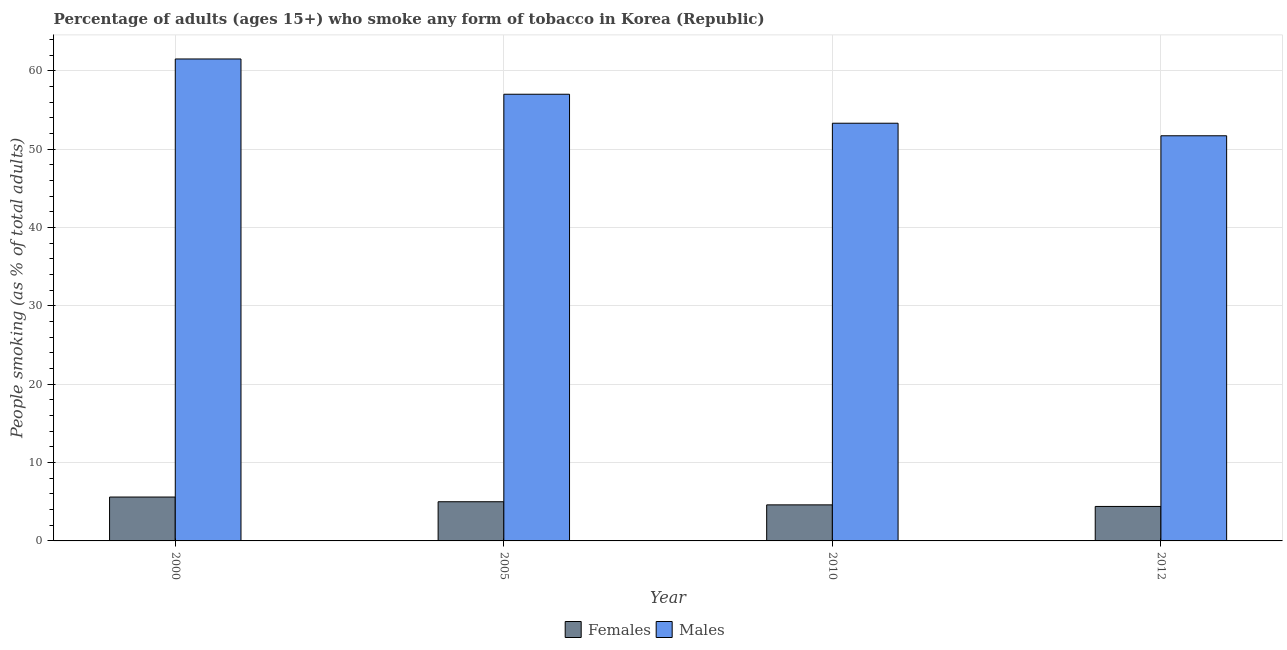How many different coloured bars are there?
Give a very brief answer. 2. Are the number of bars per tick equal to the number of legend labels?
Offer a terse response. Yes. How many bars are there on the 1st tick from the right?
Give a very brief answer. 2. What is the label of the 2nd group of bars from the left?
Offer a very short reply. 2005. In how many cases, is the number of bars for a given year not equal to the number of legend labels?
Keep it short and to the point. 0. Across all years, what is the minimum percentage of males who smoke?
Ensure brevity in your answer.  51.7. In which year was the percentage of females who smoke maximum?
Your answer should be compact. 2000. What is the total percentage of males who smoke in the graph?
Offer a terse response. 223.5. What is the difference between the percentage of females who smoke in 2000 and that in 2012?
Offer a terse response. 1.2. What is the average percentage of males who smoke per year?
Provide a short and direct response. 55.88. In the year 2005, what is the difference between the percentage of males who smoke and percentage of females who smoke?
Your answer should be very brief. 0. What is the ratio of the percentage of females who smoke in 2000 to that in 2012?
Your answer should be very brief. 1.27. Is the percentage of females who smoke in 2005 less than that in 2010?
Make the answer very short. No. What is the difference between the highest and the second highest percentage of males who smoke?
Provide a succinct answer. 4.5. What is the difference between the highest and the lowest percentage of females who smoke?
Your answer should be compact. 1.2. In how many years, is the percentage of females who smoke greater than the average percentage of females who smoke taken over all years?
Keep it short and to the point. 2. What does the 2nd bar from the left in 2005 represents?
Your answer should be compact. Males. What does the 1st bar from the right in 2000 represents?
Keep it short and to the point. Males. How many bars are there?
Your answer should be very brief. 8. How many years are there in the graph?
Ensure brevity in your answer.  4. What is the difference between two consecutive major ticks on the Y-axis?
Your response must be concise. 10. Does the graph contain any zero values?
Provide a succinct answer. No. Does the graph contain grids?
Ensure brevity in your answer.  Yes. Where does the legend appear in the graph?
Your answer should be compact. Bottom center. How are the legend labels stacked?
Make the answer very short. Horizontal. What is the title of the graph?
Your answer should be compact. Percentage of adults (ages 15+) who smoke any form of tobacco in Korea (Republic). What is the label or title of the Y-axis?
Provide a short and direct response. People smoking (as % of total adults). What is the People smoking (as % of total adults) of Females in 2000?
Provide a succinct answer. 5.6. What is the People smoking (as % of total adults) in Males in 2000?
Provide a short and direct response. 61.5. What is the People smoking (as % of total adults) in Males in 2005?
Provide a short and direct response. 57. What is the People smoking (as % of total adults) of Males in 2010?
Ensure brevity in your answer.  53.3. What is the People smoking (as % of total adults) of Females in 2012?
Your answer should be compact. 4.4. What is the People smoking (as % of total adults) of Males in 2012?
Provide a succinct answer. 51.7. Across all years, what is the maximum People smoking (as % of total adults) of Females?
Your answer should be compact. 5.6. Across all years, what is the maximum People smoking (as % of total adults) of Males?
Give a very brief answer. 61.5. Across all years, what is the minimum People smoking (as % of total adults) in Females?
Your response must be concise. 4.4. Across all years, what is the minimum People smoking (as % of total adults) of Males?
Provide a short and direct response. 51.7. What is the total People smoking (as % of total adults) in Females in the graph?
Give a very brief answer. 19.6. What is the total People smoking (as % of total adults) of Males in the graph?
Offer a very short reply. 223.5. What is the difference between the People smoking (as % of total adults) of Females in 2000 and that in 2005?
Your answer should be very brief. 0.6. What is the difference between the People smoking (as % of total adults) of Males in 2000 and that in 2005?
Provide a succinct answer. 4.5. What is the difference between the People smoking (as % of total adults) of Females in 2000 and that in 2010?
Your answer should be very brief. 1. What is the difference between the People smoking (as % of total adults) in Males in 2000 and that in 2010?
Your answer should be compact. 8.2. What is the difference between the People smoking (as % of total adults) of Females in 2005 and that in 2010?
Give a very brief answer. 0.4. What is the difference between the People smoking (as % of total adults) of Males in 2005 and that in 2010?
Offer a terse response. 3.7. What is the difference between the People smoking (as % of total adults) in Females in 2005 and that in 2012?
Provide a short and direct response. 0.6. What is the difference between the People smoking (as % of total adults) of Females in 2010 and that in 2012?
Provide a succinct answer. 0.2. What is the difference between the People smoking (as % of total adults) in Females in 2000 and the People smoking (as % of total adults) in Males in 2005?
Your answer should be very brief. -51.4. What is the difference between the People smoking (as % of total adults) in Females in 2000 and the People smoking (as % of total adults) in Males in 2010?
Provide a short and direct response. -47.7. What is the difference between the People smoking (as % of total adults) in Females in 2000 and the People smoking (as % of total adults) in Males in 2012?
Your answer should be compact. -46.1. What is the difference between the People smoking (as % of total adults) in Females in 2005 and the People smoking (as % of total adults) in Males in 2010?
Your answer should be very brief. -48.3. What is the difference between the People smoking (as % of total adults) in Females in 2005 and the People smoking (as % of total adults) in Males in 2012?
Your response must be concise. -46.7. What is the difference between the People smoking (as % of total adults) in Females in 2010 and the People smoking (as % of total adults) in Males in 2012?
Your answer should be very brief. -47.1. What is the average People smoking (as % of total adults) of Males per year?
Your answer should be very brief. 55.88. In the year 2000, what is the difference between the People smoking (as % of total adults) of Females and People smoking (as % of total adults) of Males?
Your response must be concise. -55.9. In the year 2005, what is the difference between the People smoking (as % of total adults) in Females and People smoking (as % of total adults) in Males?
Your answer should be compact. -52. In the year 2010, what is the difference between the People smoking (as % of total adults) of Females and People smoking (as % of total adults) of Males?
Your answer should be compact. -48.7. In the year 2012, what is the difference between the People smoking (as % of total adults) in Females and People smoking (as % of total adults) in Males?
Ensure brevity in your answer.  -47.3. What is the ratio of the People smoking (as % of total adults) in Females in 2000 to that in 2005?
Your answer should be compact. 1.12. What is the ratio of the People smoking (as % of total adults) in Males in 2000 to that in 2005?
Your answer should be compact. 1.08. What is the ratio of the People smoking (as % of total adults) in Females in 2000 to that in 2010?
Give a very brief answer. 1.22. What is the ratio of the People smoking (as % of total adults) of Males in 2000 to that in 2010?
Give a very brief answer. 1.15. What is the ratio of the People smoking (as % of total adults) of Females in 2000 to that in 2012?
Ensure brevity in your answer.  1.27. What is the ratio of the People smoking (as % of total adults) of Males in 2000 to that in 2012?
Your answer should be very brief. 1.19. What is the ratio of the People smoking (as % of total adults) of Females in 2005 to that in 2010?
Keep it short and to the point. 1.09. What is the ratio of the People smoking (as % of total adults) in Males in 2005 to that in 2010?
Give a very brief answer. 1.07. What is the ratio of the People smoking (as % of total adults) of Females in 2005 to that in 2012?
Give a very brief answer. 1.14. What is the ratio of the People smoking (as % of total adults) in Males in 2005 to that in 2012?
Offer a terse response. 1.1. What is the ratio of the People smoking (as % of total adults) of Females in 2010 to that in 2012?
Give a very brief answer. 1.05. What is the ratio of the People smoking (as % of total adults) in Males in 2010 to that in 2012?
Your response must be concise. 1.03. What is the difference between the highest and the second highest People smoking (as % of total adults) in Females?
Your answer should be compact. 0.6. What is the difference between the highest and the second highest People smoking (as % of total adults) in Males?
Offer a very short reply. 4.5. What is the difference between the highest and the lowest People smoking (as % of total adults) of Males?
Keep it short and to the point. 9.8. 